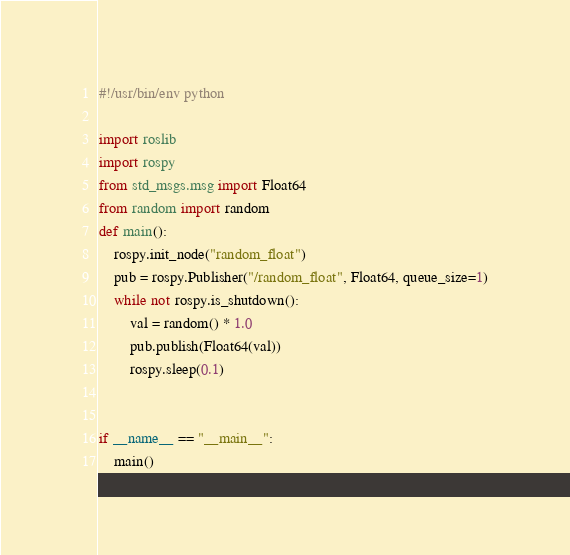<code> <loc_0><loc_0><loc_500><loc_500><_Python_>#!/usr/bin/env python

import roslib
import rospy
from std_msgs.msg import Float64
from random import random
def main():
    rospy.init_node("random_float")
    pub = rospy.Publisher("/random_float", Float64, queue_size=1)
    while not rospy.is_shutdown():
        val = random() * 1.0
        pub.publish(Float64(val))
        rospy.sleep(0.1)


if __name__ == "__main__":
    main()
</code> 